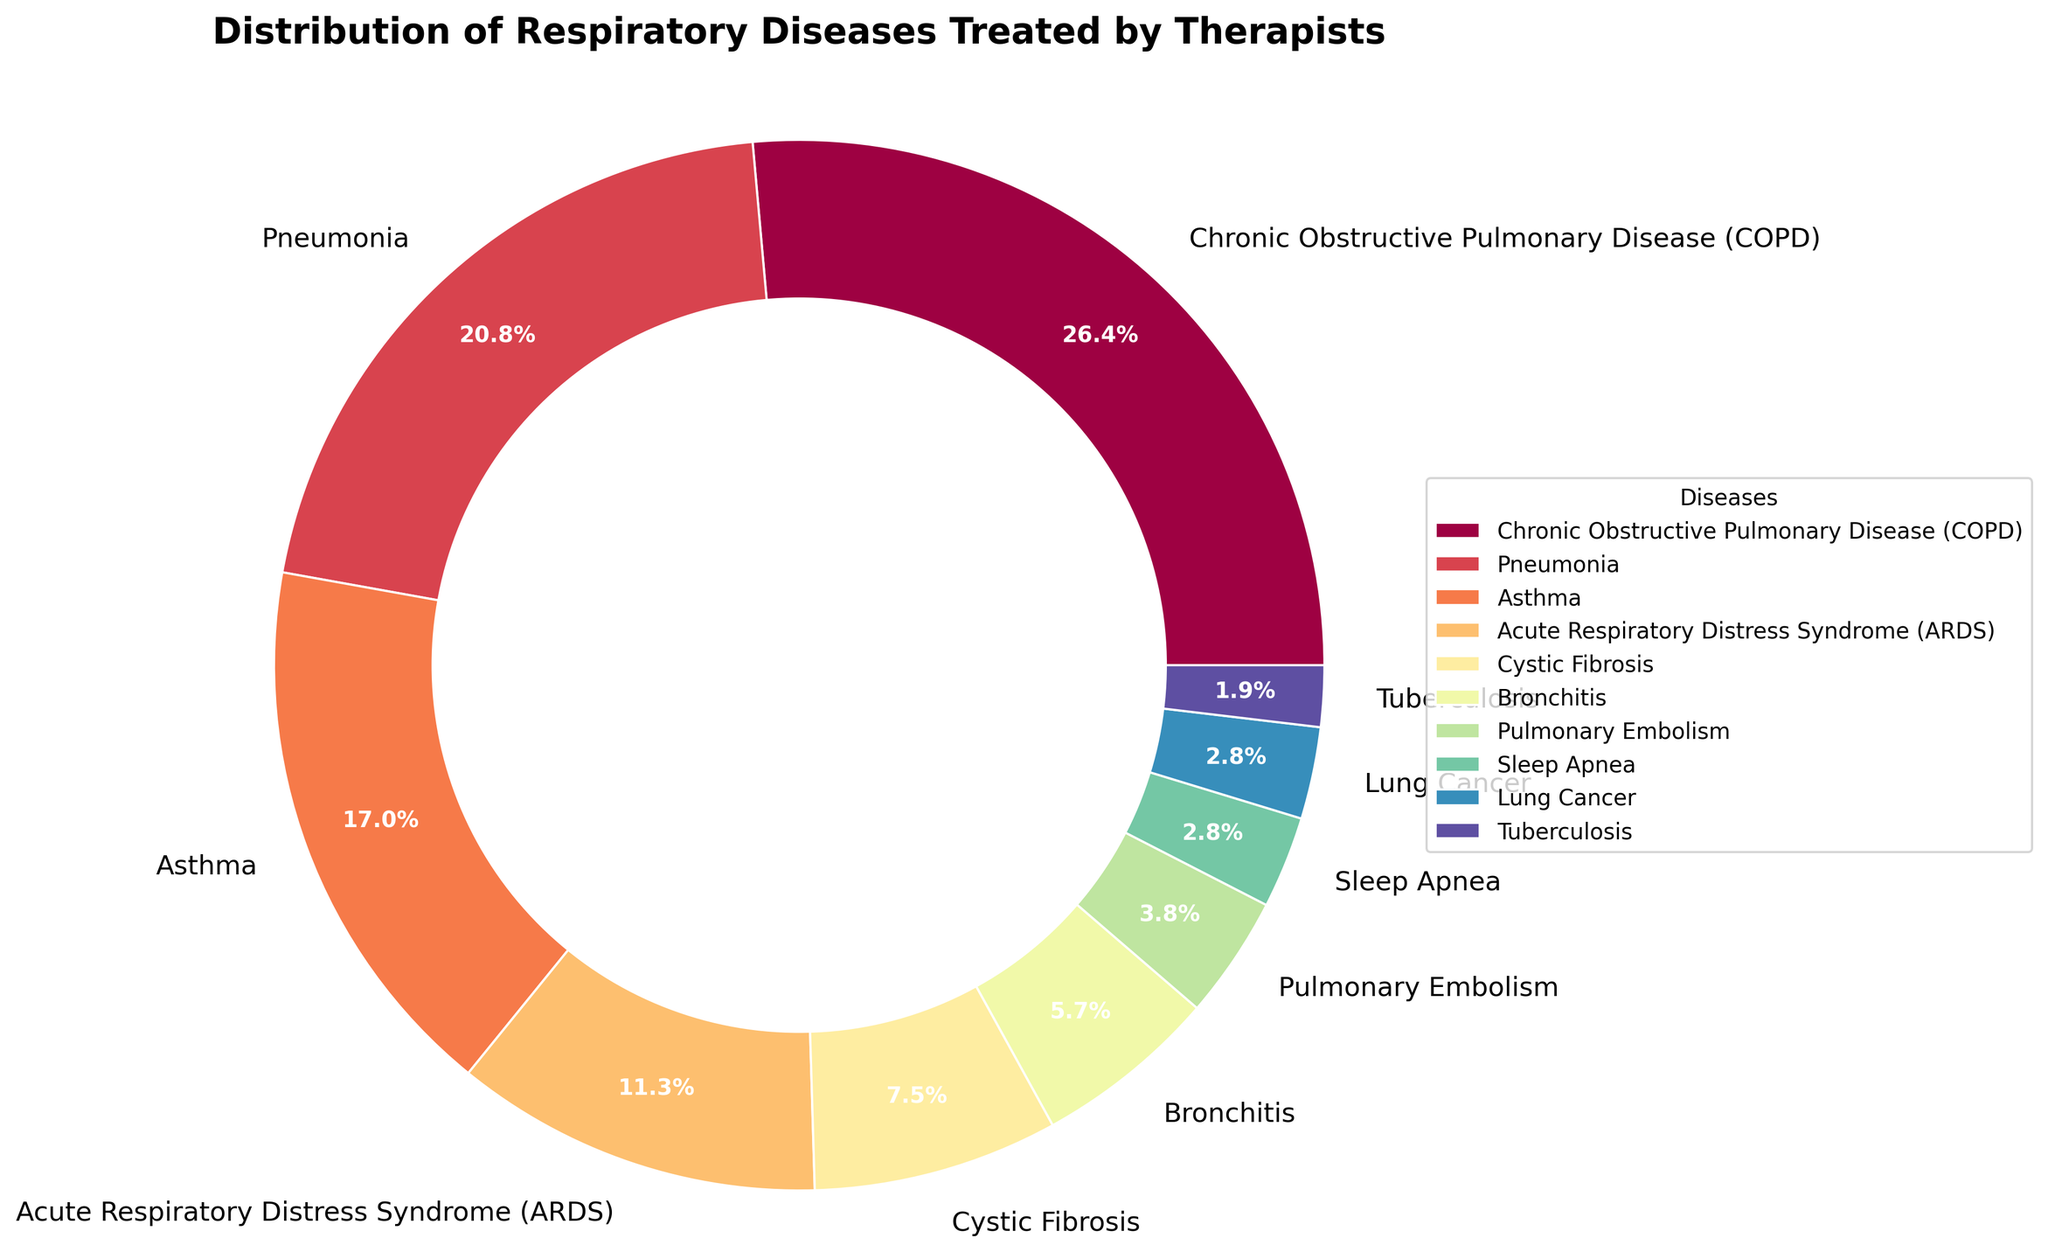Which disease is the most commonly treated by respiratory therapists according to the chart? The chart shows various diseases treated by respiratory therapists. The disease with the largest slice in the pie chart is Chronic Obstructive Pulmonary Disease (COPD), with 28%.
Answer: COPD Which two diseases combined account for half of the cases treated by respiratory therapists? According to the chart, COPD accounts for 28% and Pneumonia accounts for 22%. Adding these two percentages together: 28% + 22% = 50%. So, COPD and Pneumonia together account for half of the cases.
Answer: COPD and Pneumonia What percentage of cases are caused by Asthma? The pie chart shows that the slice representing Asthma has a percentage label of 18%.
Answer: 18% What is the difference in percentage between ARDS and Cystic Fibrosis cases? The pie chart shows ARDS cases at 12% and Cystic Fibrosis cases at 8%. The difference is calculated as 12% - 8% = 4%.
Answer: 4% Which disease has a higher percentage of cases: Bronchitis or Pulmonary Embolism? Looking at the pie chart, Bronchitis has 6%, whereas Pulmonary Embolism has 4%, so Bronchitis has a higher percentage of cases.
Answer: Bronchitis How many diseases account for less than 5% each of the total cases treated by respiratory therapists? The diseases with less than 5% are Pulmonary Embolism (4%), Sleep Apnea (3%), Lung Cancer (3%), and Tuberculosis (2%). Counting these diseases, there are 4 in total.
Answer: 4 What is the combined percentage of Sleep Apnea and Lung Cancer cases? The chart shows Sleep Apnea at 3% and Lung Cancer also at 3%. Adding these percentages gives 3% + 3% = 6%.
Answer: 6% Which visual attribute helps distinguish each disease's proportion in the pie chart? The different colors assigned to each slice in the chart help distinguish the proportions of each disease.
Answer: Colors Are there any diseases in the chart that have an equal percentage of cases? If so, which ones? Yes, according to the chart, both Sleep Apnea and Lung Cancer each account for 3% of the cases.
Answer: Sleep Apnea and Lung Cancer What is the total percentage of the three least common diseases treated by respiratory therapists? The least common diseases and their percentages are Tuberculosis (2%), Sleep Apnea (3%), and Lung Cancer (3%). Adding these together: 2% + 3% + 3% = 8%.
Answer: 8% 